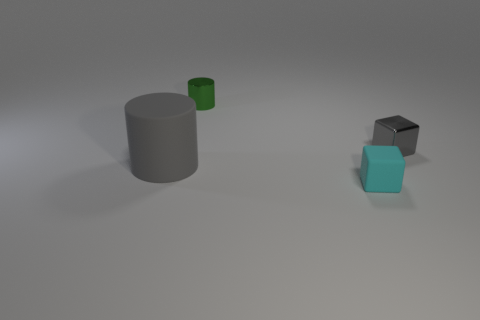Add 3 big gray rubber cylinders. How many objects exist? 7 Subtract all small cyan rubber cubes. Subtract all tiny cubes. How many objects are left? 1 Add 3 metallic things. How many metallic things are left? 5 Add 3 big blue metallic blocks. How many big blue metallic blocks exist? 3 Subtract 0 brown cylinders. How many objects are left? 4 